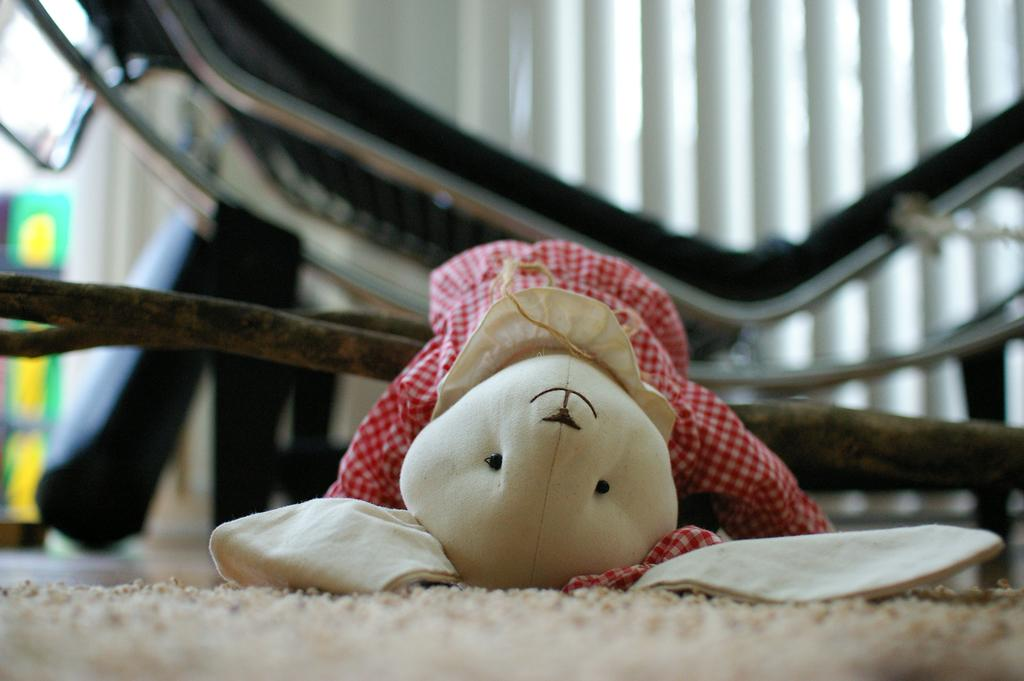What is the main subject in the center of the image? There is a soft toy in the center of the image. Where is the soft toy located? The soft toy is on the floor. Can you describe the background of the image? The background of the image is blurry. What furniture can be seen in the background? There is a sleeping chair in the background. What else is present in the background? There is a curtain in the background. What is at the bottom of the image? There is a mat at the bottom of the image. What type of liquid is being poured from the finger in the image? There is no liquid or finger present in the image. What brand of soda is being advertised in the image? There is no soda or advertisement present in the image. 